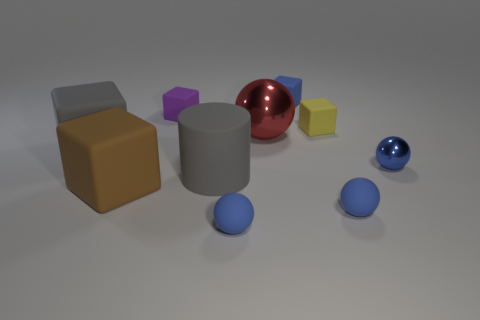Is there a cylinder behind the blue ball behind the gray object that is right of the big brown rubber cube?
Ensure brevity in your answer.  No. Are there any other things that have the same size as the yellow thing?
Your answer should be very brief. Yes. There is a big cylinder that is made of the same material as the blue block; what color is it?
Give a very brief answer. Gray. What is the size of the blue matte thing that is in front of the tiny shiny object and on the right side of the big red metal object?
Ensure brevity in your answer.  Small. Are there fewer blue metallic spheres behind the tiny blue block than brown matte things behind the small yellow block?
Keep it short and to the point. No. Is the material of the small blue ball that is to the left of the large sphere the same as the gray object that is to the left of the purple rubber block?
Keep it short and to the point. Yes. What is the material of the block that is the same color as the small shiny sphere?
Make the answer very short. Rubber. There is a rubber thing that is to the right of the big red ball and in front of the yellow thing; what shape is it?
Make the answer very short. Sphere. What is the tiny ball that is to the left of the object behind the tiny purple matte thing made of?
Give a very brief answer. Rubber. Are there more small green metallic balls than blue matte spheres?
Offer a terse response. No. 